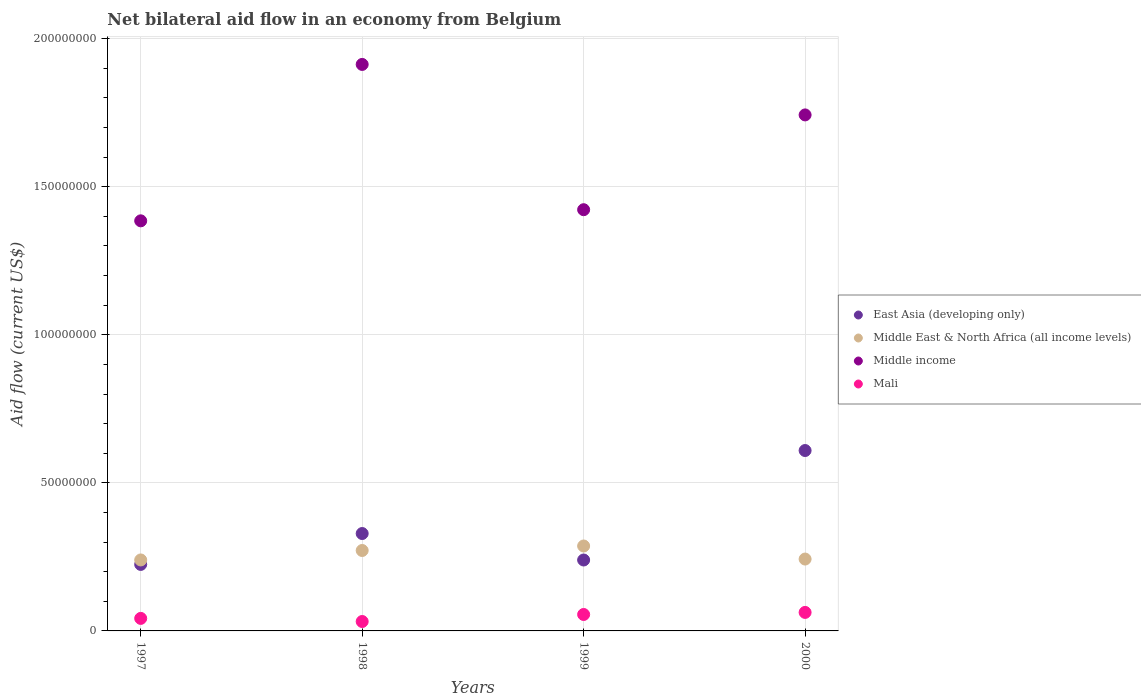What is the net bilateral aid flow in East Asia (developing only) in 2000?
Keep it short and to the point. 6.09e+07. Across all years, what is the maximum net bilateral aid flow in Mali?
Provide a short and direct response. 6.25e+06. Across all years, what is the minimum net bilateral aid flow in Mali?
Offer a terse response. 3.18e+06. What is the total net bilateral aid flow in East Asia (developing only) in the graph?
Keep it short and to the point. 1.40e+08. What is the difference between the net bilateral aid flow in Mali in 1999 and that in 2000?
Ensure brevity in your answer.  -7.00e+05. What is the difference between the net bilateral aid flow in Middle East & North Africa (all income levels) in 1998 and the net bilateral aid flow in Mali in 1997?
Ensure brevity in your answer.  2.29e+07. What is the average net bilateral aid flow in Middle East & North Africa (all income levels) per year?
Offer a terse response. 2.60e+07. In the year 1997, what is the difference between the net bilateral aid flow in East Asia (developing only) and net bilateral aid flow in Middle East & North Africa (all income levels)?
Give a very brief answer. -1.51e+06. In how many years, is the net bilateral aid flow in Middle income greater than 30000000 US$?
Offer a terse response. 4. What is the ratio of the net bilateral aid flow in Mali in 1997 to that in 1999?
Ensure brevity in your answer.  0.76. What is the difference between the highest and the second highest net bilateral aid flow in East Asia (developing only)?
Provide a succinct answer. 2.80e+07. What is the difference between the highest and the lowest net bilateral aid flow in Middle income?
Provide a succinct answer. 5.28e+07. In how many years, is the net bilateral aid flow in Middle East & North Africa (all income levels) greater than the average net bilateral aid flow in Middle East & North Africa (all income levels) taken over all years?
Make the answer very short. 2. Is the sum of the net bilateral aid flow in Middle East & North Africa (all income levels) in 1997 and 1998 greater than the maximum net bilateral aid flow in Middle income across all years?
Keep it short and to the point. No. Is it the case that in every year, the sum of the net bilateral aid flow in Mali and net bilateral aid flow in Middle income  is greater than the net bilateral aid flow in East Asia (developing only)?
Ensure brevity in your answer.  Yes. Is the net bilateral aid flow in Middle East & North Africa (all income levels) strictly greater than the net bilateral aid flow in Middle income over the years?
Provide a short and direct response. No. How many dotlines are there?
Your answer should be very brief. 4. How many years are there in the graph?
Offer a terse response. 4. What is the difference between two consecutive major ticks on the Y-axis?
Your answer should be compact. 5.00e+07. Where does the legend appear in the graph?
Ensure brevity in your answer.  Center right. How are the legend labels stacked?
Keep it short and to the point. Vertical. What is the title of the graph?
Provide a short and direct response. Net bilateral aid flow in an economy from Belgium. What is the label or title of the X-axis?
Give a very brief answer. Years. What is the label or title of the Y-axis?
Your response must be concise. Aid flow (current US$). What is the Aid flow (current US$) of East Asia (developing only) in 1997?
Provide a succinct answer. 2.25e+07. What is the Aid flow (current US$) in Middle East & North Africa (all income levels) in 1997?
Your answer should be very brief. 2.40e+07. What is the Aid flow (current US$) in Middle income in 1997?
Give a very brief answer. 1.38e+08. What is the Aid flow (current US$) in Mali in 1997?
Your answer should be very brief. 4.23e+06. What is the Aid flow (current US$) in East Asia (developing only) in 1998?
Provide a short and direct response. 3.29e+07. What is the Aid flow (current US$) in Middle East & North Africa (all income levels) in 1998?
Ensure brevity in your answer.  2.72e+07. What is the Aid flow (current US$) in Middle income in 1998?
Your answer should be compact. 1.91e+08. What is the Aid flow (current US$) in Mali in 1998?
Make the answer very short. 3.18e+06. What is the Aid flow (current US$) of East Asia (developing only) in 1999?
Keep it short and to the point. 2.40e+07. What is the Aid flow (current US$) in Middle East & North Africa (all income levels) in 1999?
Your answer should be compact. 2.87e+07. What is the Aid flow (current US$) in Middle income in 1999?
Your answer should be very brief. 1.42e+08. What is the Aid flow (current US$) in Mali in 1999?
Your answer should be very brief. 5.55e+06. What is the Aid flow (current US$) in East Asia (developing only) in 2000?
Offer a terse response. 6.09e+07. What is the Aid flow (current US$) of Middle East & North Africa (all income levels) in 2000?
Your answer should be compact. 2.43e+07. What is the Aid flow (current US$) in Middle income in 2000?
Give a very brief answer. 1.74e+08. What is the Aid flow (current US$) in Mali in 2000?
Give a very brief answer. 6.25e+06. Across all years, what is the maximum Aid flow (current US$) in East Asia (developing only)?
Offer a terse response. 6.09e+07. Across all years, what is the maximum Aid flow (current US$) in Middle East & North Africa (all income levels)?
Offer a very short reply. 2.87e+07. Across all years, what is the maximum Aid flow (current US$) of Middle income?
Offer a very short reply. 1.91e+08. Across all years, what is the maximum Aid flow (current US$) in Mali?
Your answer should be very brief. 6.25e+06. Across all years, what is the minimum Aid flow (current US$) of East Asia (developing only)?
Provide a short and direct response. 2.25e+07. Across all years, what is the minimum Aid flow (current US$) in Middle East & North Africa (all income levels)?
Your response must be concise. 2.40e+07. Across all years, what is the minimum Aid flow (current US$) in Middle income?
Provide a short and direct response. 1.38e+08. Across all years, what is the minimum Aid flow (current US$) of Mali?
Offer a terse response. 3.18e+06. What is the total Aid flow (current US$) in East Asia (developing only) in the graph?
Offer a very short reply. 1.40e+08. What is the total Aid flow (current US$) in Middle East & North Africa (all income levels) in the graph?
Provide a short and direct response. 1.04e+08. What is the total Aid flow (current US$) in Middle income in the graph?
Give a very brief answer. 6.46e+08. What is the total Aid flow (current US$) of Mali in the graph?
Give a very brief answer. 1.92e+07. What is the difference between the Aid flow (current US$) in East Asia (developing only) in 1997 and that in 1998?
Your answer should be very brief. -1.04e+07. What is the difference between the Aid flow (current US$) in Middle East & North Africa (all income levels) in 1997 and that in 1998?
Your answer should be compact. -3.19e+06. What is the difference between the Aid flow (current US$) in Middle income in 1997 and that in 1998?
Offer a terse response. -5.28e+07. What is the difference between the Aid flow (current US$) in Mali in 1997 and that in 1998?
Provide a short and direct response. 1.05e+06. What is the difference between the Aid flow (current US$) of East Asia (developing only) in 1997 and that in 1999?
Your answer should be compact. -1.49e+06. What is the difference between the Aid flow (current US$) of Middle East & North Africa (all income levels) in 1997 and that in 1999?
Provide a succinct answer. -4.71e+06. What is the difference between the Aid flow (current US$) in Middle income in 1997 and that in 1999?
Offer a terse response. -3.76e+06. What is the difference between the Aid flow (current US$) of Mali in 1997 and that in 1999?
Give a very brief answer. -1.32e+06. What is the difference between the Aid flow (current US$) in East Asia (developing only) in 1997 and that in 2000?
Your answer should be very brief. -3.85e+07. What is the difference between the Aid flow (current US$) in Middle East & North Africa (all income levels) in 1997 and that in 2000?
Your answer should be very brief. -3.00e+05. What is the difference between the Aid flow (current US$) of Middle income in 1997 and that in 2000?
Give a very brief answer. -3.58e+07. What is the difference between the Aid flow (current US$) in Mali in 1997 and that in 2000?
Make the answer very short. -2.02e+06. What is the difference between the Aid flow (current US$) of East Asia (developing only) in 1998 and that in 1999?
Offer a very short reply. 8.94e+06. What is the difference between the Aid flow (current US$) in Middle East & North Africa (all income levels) in 1998 and that in 1999?
Your answer should be very brief. -1.52e+06. What is the difference between the Aid flow (current US$) in Middle income in 1998 and that in 1999?
Provide a short and direct response. 4.91e+07. What is the difference between the Aid flow (current US$) in Mali in 1998 and that in 1999?
Keep it short and to the point. -2.37e+06. What is the difference between the Aid flow (current US$) of East Asia (developing only) in 1998 and that in 2000?
Keep it short and to the point. -2.80e+07. What is the difference between the Aid flow (current US$) of Middle East & North Africa (all income levels) in 1998 and that in 2000?
Provide a succinct answer. 2.89e+06. What is the difference between the Aid flow (current US$) in Middle income in 1998 and that in 2000?
Your answer should be compact. 1.70e+07. What is the difference between the Aid flow (current US$) in Mali in 1998 and that in 2000?
Provide a succinct answer. -3.07e+06. What is the difference between the Aid flow (current US$) in East Asia (developing only) in 1999 and that in 2000?
Offer a very short reply. -3.70e+07. What is the difference between the Aid flow (current US$) in Middle East & North Africa (all income levels) in 1999 and that in 2000?
Provide a succinct answer. 4.41e+06. What is the difference between the Aid flow (current US$) in Middle income in 1999 and that in 2000?
Keep it short and to the point. -3.20e+07. What is the difference between the Aid flow (current US$) in Mali in 1999 and that in 2000?
Your answer should be very brief. -7.00e+05. What is the difference between the Aid flow (current US$) in East Asia (developing only) in 1997 and the Aid flow (current US$) in Middle East & North Africa (all income levels) in 1998?
Offer a terse response. -4.70e+06. What is the difference between the Aid flow (current US$) of East Asia (developing only) in 1997 and the Aid flow (current US$) of Middle income in 1998?
Your answer should be very brief. -1.69e+08. What is the difference between the Aid flow (current US$) in East Asia (developing only) in 1997 and the Aid flow (current US$) in Mali in 1998?
Give a very brief answer. 1.93e+07. What is the difference between the Aid flow (current US$) of Middle East & North Africa (all income levels) in 1997 and the Aid flow (current US$) of Middle income in 1998?
Offer a very short reply. -1.67e+08. What is the difference between the Aid flow (current US$) in Middle East & North Africa (all income levels) in 1997 and the Aid flow (current US$) in Mali in 1998?
Ensure brevity in your answer.  2.08e+07. What is the difference between the Aid flow (current US$) of Middle income in 1997 and the Aid flow (current US$) of Mali in 1998?
Provide a succinct answer. 1.35e+08. What is the difference between the Aid flow (current US$) in East Asia (developing only) in 1997 and the Aid flow (current US$) in Middle East & North Africa (all income levels) in 1999?
Your answer should be very brief. -6.22e+06. What is the difference between the Aid flow (current US$) of East Asia (developing only) in 1997 and the Aid flow (current US$) of Middle income in 1999?
Your answer should be compact. -1.20e+08. What is the difference between the Aid flow (current US$) of East Asia (developing only) in 1997 and the Aid flow (current US$) of Mali in 1999?
Ensure brevity in your answer.  1.69e+07. What is the difference between the Aid flow (current US$) of Middle East & North Africa (all income levels) in 1997 and the Aid flow (current US$) of Middle income in 1999?
Offer a terse response. -1.18e+08. What is the difference between the Aid flow (current US$) in Middle East & North Africa (all income levels) in 1997 and the Aid flow (current US$) in Mali in 1999?
Your answer should be very brief. 1.84e+07. What is the difference between the Aid flow (current US$) in Middle income in 1997 and the Aid flow (current US$) in Mali in 1999?
Provide a short and direct response. 1.33e+08. What is the difference between the Aid flow (current US$) of East Asia (developing only) in 1997 and the Aid flow (current US$) of Middle East & North Africa (all income levels) in 2000?
Ensure brevity in your answer.  -1.81e+06. What is the difference between the Aid flow (current US$) of East Asia (developing only) in 1997 and the Aid flow (current US$) of Middle income in 2000?
Your answer should be compact. -1.52e+08. What is the difference between the Aid flow (current US$) in East Asia (developing only) in 1997 and the Aid flow (current US$) in Mali in 2000?
Provide a short and direct response. 1.62e+07. What is the difference between the Aid flow (current US$) of Middle East & North Africa (all income levels) in 1997 and the Aid flow (current US$) of Middle income in 2000?
Your answer should be very brief. -1.50e+08. What is the difference between the Aid flow (current US$) in Middle East & North Africa (all income levels) in 1997 and the Aid flow (current US$) in Mali in 2000?
Offer a very short reply. 1.77e+07. What is the difference between the Aid flow (current US$) of Middle income in 1997 and the Aid flow (current US$) of Mali in 2000?
Your answer should be very brief. 1.32e+08. What is the difference between the Aid flow (current US$) of East Asia (developing only) in 1998 and the Aid flow (current US$) of Middle East & North Africa (all income levels) in 1999?
Offer a very short reply. 4.21e+06. What is the difference between the Aid flow (current US$) in East Asia (developing only) in 1998 and the Aid flow (current US$) in Middle income in 1999?
Make the answer very short. -1.09e+08. What is the difference between the Aid flow (current US$) of East Asia (developing only) in 1998 and the Aid flow (current US$) of Mali in 1999?
Offer a terse response. 2.73e+07. What is the difference between the Aid flow (current US$) of Middle East & North Africa (all income levels) in 1998 and the Aid flow (current US$) of Middle income in 1999?
Keep it short and to the point. -1.15e+08. What is the difference between the Aid flow (current US$) of Middle East & North Africa (all income levels) in 1998 and the Aid flow (current US$) of Mali in 1999?
Provide a short and direct response. 2.16e+07. What is the difference between the Aid flow (current US$) of Middle income in 1998 and the Aid flow (current US$) of Mali in 1999?
Provide a succinct answer. 1.86e+08. What is the difference between the Aid flow (current US$) in East Asia (developing only) in 1998 and the Aid flow (current US$) in Middle East & North Africa (all income levels) in 2000?
Offer a very short reply. 8.62e+06. What is the difference between the Aid flow (current US$) in East Asia (developing only) in 1998 and the Aid flow (current US$) in Middle income in 2000?
Provide a succinct answer. -1.41e+08. What is the difference between the Aid flow (current US$) in East Asia (developing only) in 1998 and the Aid flow (current US$) in Mali in 2000?
Offer a very short reply. 2.66e+07. What is the difference between the Aid flow (current US$) in Middle East & North Africa (all income levels) in 1998 and the Aid flow (current US$) in Middle income in 2000?
Give a very brief answer. -1.47e+08. What is the difference between the Aid flow (current US$) of Middle East & North Africa (all income levels) in 1998 and the Aid flow (current US$) of Mali in 2000?
Provide a short and direct response. 2.09e+07. What is the difference between the Aid flow (current US$) in Middle income in 1998 and the Aid flow (current US$) in Mali in 2000?
Keep it short and to the point. 1.85e+08. What is the difference between the Aid flow (current US$) in East Asia (developing only) in 1999 and the Aid flow (current US$) in Middle East & North Africa (all income levels) in 2000?
Your response must be concise. -3.20e+05. What is the difference between the Aid flow (current US$) of East Asia (developing only) in 1999 and the Aid flow (current US$) of Middle income in 2000?
Keep it short and to the point. -1.50e+08. What is the difference between the Aid flow (current US$) in East Asia (developing only) in 1999 and the Aid flow (current US$) in Mali in 2000?
Provide a succinct answer. 1.77e+07. What is the difference between the Aid flow (current US$) in Middle East & North Africa (all income levels) in 1999 and the Aid flow (current US$) in Middle income in 2000?
Provide a short and direct response. -1.46e+08. What is the difference between the Aid flow (current US$) in Middle East & North Africa (all income levels) in 1999 and the Aid flow (current US$) in Mali in 2000?
Your answer should be compact. 2.24e+07. What is the difference between the Aid flow (current US$) in Middle income in 1999 and the Aid flow (current US$) in Mali in 2000?
Provide a succinct answer. 1.36e+08. What is the average Aid flow (current US$) in East Asia (developing only) per year?
Your answer should be compact. 3.51e+07. What is the average Aid flow (current US$) of Middle East & North Africa (all income levels) per year?
Make the answer very short. 2.60e+07. What is the average Aid flow (current US$) of Middle income per year?
Keep it short and to the point. 1.62e+08. What is the average Aid flow (current US$) in Mali per year?
Give a very brief answer. 4.80e+06. In the year 1997, what is the difference between the Aid flow (current US$) in East Asia (developing only) and Aid flow (current US$) in Middle East & North Africa (all income levels)?
Offer a terse response. -1.51e+06. In the year 1997, what is the difference between the Aid flow (current US$) in East Asia (developing only) and Aid flow (current US$) in Middle income?
Your response must be concise. -1.16e+08. In the year 1997, what is the difference between the Aid flow (current US$) in East Asia (developing only) and Aid flow (current US$) in Mali?
Make the answer very short. 1.82e+07. In the year 1997, what is the difference between the Aid flow (current US$) of Middle East & North Africa (all income levels) and Aid flow (current US$) of Middle income?
Make the answer very short. -1.15e+08. In the year 1997, what is the difference between the Aid flow (current US$) of Middle East & North Africa (all income levels) and Aid flow (current US$) of Mali?
Ensure brevity in your answer.  1.97e+07. In the year 1997, what is the difference between the Aid flow (current US$) in Middle income and Aid flow (current US$) in Mali?
Keep it short and to the point. 1.34e+08. In the year 1998, what is the difference between the Aid flow (current US$) in East Asia (developing only) and Aid flow (current US$) in Middle East & North Africa (all income levels)?
Make the answer very short. 5.73e+06. In the year 1998, what is the difference between the Aid flow (current US$) in East Asia (developing only) and Aid flow (current US$) in Middle income?
Offer a terse response. -1.58e+08. In the year 1998, what is the difference between the Aid flow (current US$) in East Asia (developing only) and Aid flow (current US$) in Mali?
Ensure brevity in your answer.  2.97e+07. In the year 1998, what is the difference between the Aid flow (current US$) of Middle East & North Africa (all income levels) and Aid flow (current US$) of Middle income?
Give a very brief answer. -1.64e+08. In the year 1998, what is the difference between the Aid flow (current US$) in Middle East & North Africa (all income levels) and Aid flow (current US$) in Mali?
Provide a succinct answer. 2.40e+07. In the year 1998, what is the difference between the Aid flow (current US$) of Middle income and Aid flow (current US$) of Mali?
Ensure brevity in your answer.  1.88e+08. In the year 1999, what is the difference between the Aid flow (current US$) in East Asia (developing only) and Aid flow (current US$) in Middle East & North Africa (all income levels)?
Give a very brief answer. -4.73e+06. In the year 1999, what is the difference between the Aid flow (current US$) in East Asia (developing only) and Aid flow (current US$) in Middle income?
Your answer should be compact. -1.18e+08. In the year 1999, what is the difference between the Aid flow (current US$) in East Asia (developing only) and Aid flow (current US$) in Mali?
Keep it short and to the point. 1.84e+07. In the year 1999, what is the difference between the Aid flow (current US$) in Middle East & North Africa (all income levels) and Aid flow (current US$) in Middle income?
Ensure brevity in your answer.  -1.14e+08. In the year 1999, what is the difference between the Aid flow (current US$) in Middle East & North Africa (all income levels) and Aid flow (current US$) in Mali?
Your answer should be compact. 2.31e+07. In the year 1999, what is the difference between the Aid flow (current US$) of Middle income and Aid flow (current US$) of Mali?
Ensure brevity in your answer.  1.37e+08. In the year 2000, what is the difference between the Aid flow (current US$) in East Asia (developing only) and Aid flow (current US$) in Middle East & North Africa (all income levels)?
Your answer should be compact. 3.66e+07. In the year 2000, what is the difference between the Aid flow (current US$) of East Asia (developing only) and Aid flow (current US$) of Middle income?
Offer a very short reply. -1.13e+08. In the year 2000, what is the difference between the Aid flow (current US$) in East Asia (developing only) and Aid flow (current US$) in Mali?
Offer a very short reply. 5.47e+07. In the year 2000, what is the difference between the Aid flow (current US$) in Middle East & North Africa (all income levels) and Aid flow (current US$) in Middle income?
Ensure brevity in your answer.  -1.50e+08. In the year 2000, what is the difference between the Aid flow (current US$) of Middle East & North Africa (all income levels) and Aid flow (current US$) of Mali?
Your answer should be very brief. 1.80e+07. In the year 2000, what is the difference between the Aid flow (current US$) in Middle income and Aid flow (current US$) in Mali?
Provide a succinct answer. 1.68e+08. What is the ratio of the Aid flow (current US$) in East Asia (developing only) in 1997 to that in 1998?
Provide a short and direct response. 0.68. What is the ratio of the Aid flow (current US$) in Middle East & North Africa (all income levels) in 1997 to that in 1998?
Your response must be concise. 0.88. What is the ratio of the Aid flow (current US$) of Middle income in 1997 to that in 1998?
Give a very brief answer. 0.72. What is the ratio of the Aid flow (current US$) in Mali in 1997 to that in 1998?
Offer a very short reply. 1.33. What is the ratio of the Aid flow (current US$) of East Asia (developing only) in 1997 to that in 1999?
Ensure brevity in your answer.  0.94. What is the ratio of the Aid flow (current US$) in Middle East & North Africa (all income levels) in 1997 to that in 1999?
Your answer should be very brief. 0.84. What is the ratio of the Aid flow (current US$) in Middle income in 1997 to that in 1999?
Ensure brevity in your answer.  0.97. What is the ratio of the Aid flow (current US$) of Mali in 1997 to that in 1999?
Provide a succinct answer. 0.76. What is the ratio of the Aid flow (current US$) of East Asia (developing only) in 1997 to that in 2000?
Provide a short and direct response. 0.37. What is the ratio of the Aid flow (current US$) of Middle East & North Africa (all income levels) in 1997 to that in 2000?
Your answer should be very brief. 0.99. What is the ratio of the Aid flow (current US$) in Middle income in 1997 to that in 2000?
Your response must be concise. 0.79. What is the ratio of the Aid flow (current US$) in Mali in 1997 to that in 2000?
Offer a terse response. 0.68. What is the ratio of the Aid flow (current US$) of East Asia (developing only) in 1998 to that in 1999?
Keep it short and to the point. 1.37. What is the ratio of the Aid flow (current US$) of Middle East & North Africa (all income levels) in 1998 to that in 1999?
Provide a short and direct response. 0.95. What is the ratio of the Aid flow (current US$) of Middle income in 1998 to that in 1999?
Give a very brief answer. 1.34. What is the ratio of the Aid flow (current US$) of Mali in 1998 to that in 1999?
Offer a very short reply. 0.57. What is the ratio of the Aid flow (current US$) of East Asia (developing only) in 1998 to that in 2000?
Offer a very short reply. 0.54. What is the ratio of the Aid flow (current US$) of Middle East & North Africa (all income levels) in 1998 to that in 2000?
Your answer should be very brief. 1.12. What is the ratio of the Aid flow (current US$) of Middle income in 1998 to that in 2000?
Offer a very short reply. 1.1. What is the ratio of the Aid flow (current US$) in Mali in 1998 to that in 2000?
Your answer should be compact. 0.51. What is the ratio of the Aid flow (current US$) of East Asia (developing only) in 1999 to that in 2000?
Give a very brief answer. 0.39. What is the ratio of the Aid flow (current US$) in Middle East & North Africa (all income levels) in 1999 to that in 2000?
Offer a terse response. 1.18. What is the ratio of the Aid flow (current US$) of Middle income in 1999 to that in 2000?
Give a very brief answer. 0.82. What is the ratio of the Aid flow (current US$) in Mali in 1999 to that in 2000?
Offer a very short reply. 0.89. What is the difference between the highest and the second highest Aid flow (current US$) in East Asia (developing only)?
Provide a short and direct response. 2.80e+07. What is the difference between the highest and the second highest Aid flow (current US$) in Middle East & North Africa (all income levels)?
Provide a short and direct response. 1.52e+06. What is the difference between the highest and the second highest Aid flow (current US$) in Middle income?
Offer a very short reply. 1.70e+07. What is the difference between the highest and the second highest Aid flow (current US$) in Mali?
Give a very brief answer. 7.00e+05. What is the difference between the highest and the lowest Aid flow (current US$) of East Asia (developing only)?
Offer a very short reply. 3.85e+07. What is the difference between the highest and the lowest Aid flow (current US$) of Middle East & North Africa (all income levels)?
Offer a terse response. 4.71e+06. What is the difference between the highest and the lowest Aid flow (current US$) of Middle income?
Make the answer very short. 5.28e+07. What is the difference between the highest and the lowest Aid flow (current US$) of Mali?
Provide a short and direct response. 3.07e+06. 